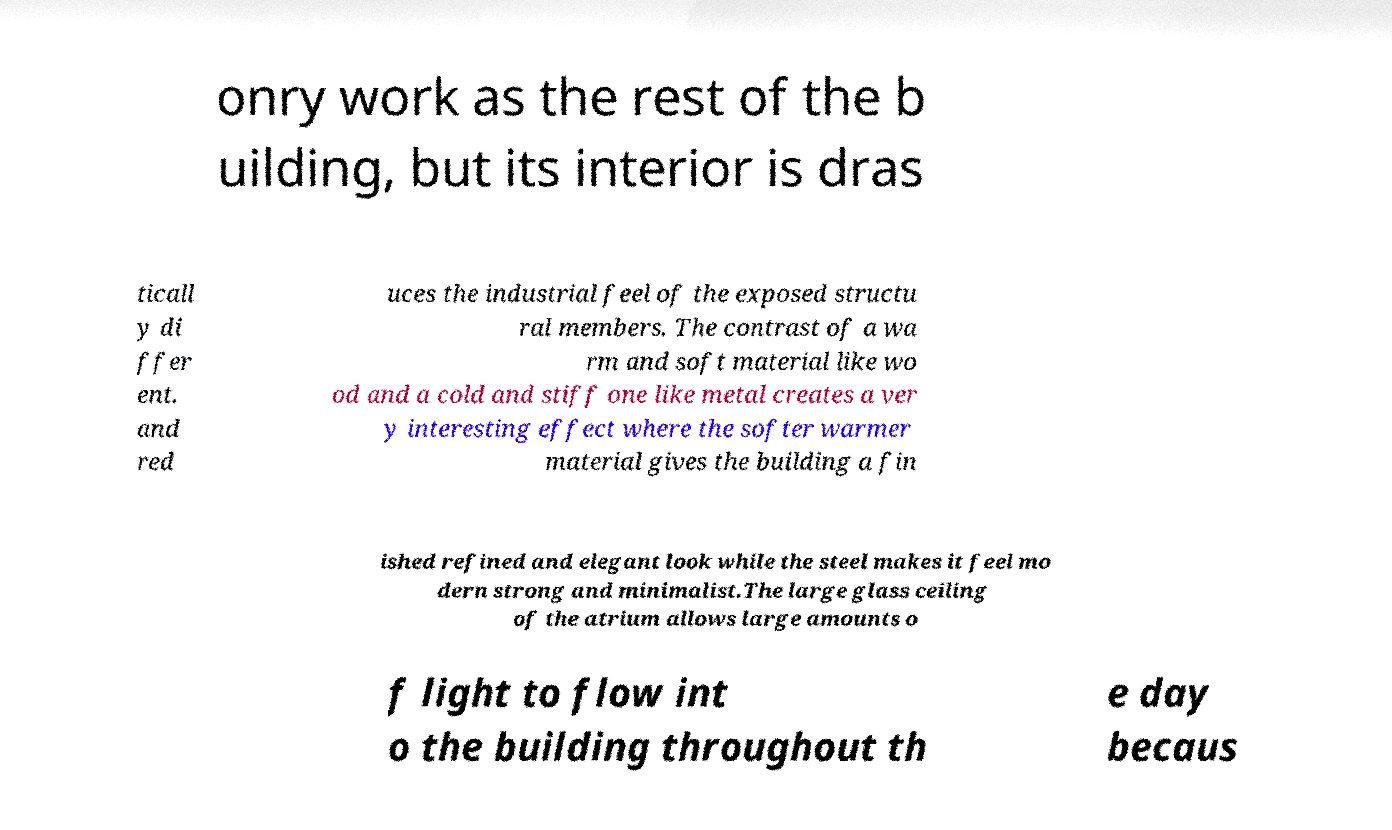There's text embedded in this image that I need extracted. Can you transcribe it verbatim? onry work as the rest of the b uilding, but its interior is dras ticall y di ffer ent. and red uces the industrial feel of the exposed structu ral members. The contrast of a wa rm and soft material like wo od and a cold and stiff one like metal creates a ver y interesting effect where the softer warmer material gives the building a fin ished refined and elegant look while the steel makes it feel mo dern strong and minimalist.The large glass ceiling of the atrium allows large amounts o f light to flow int o the building throughout th e day becaus 